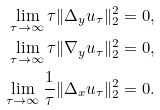Convert formula to latex. <formula><loc_0><loc_0><loc_500><loc_500>\lim _ { \tau \to \infty } \tau \| \Delta _ { y } u _ { \tau } \| _ { 2 } ^ { 2 } = 0 , \\ \lim _ { \tau \to \infty } \tau \| \nabla _ { y } u _ { \tau } \| _ { 2 } ^ { 2 } = 0 , \\ \lim _ { \tau \to \infty } \frac { 1 } { \tau } \| \Delta _ { x } u _ { \tau } \| _ { 2 } ^ { 2 } = 0 .</formula> 